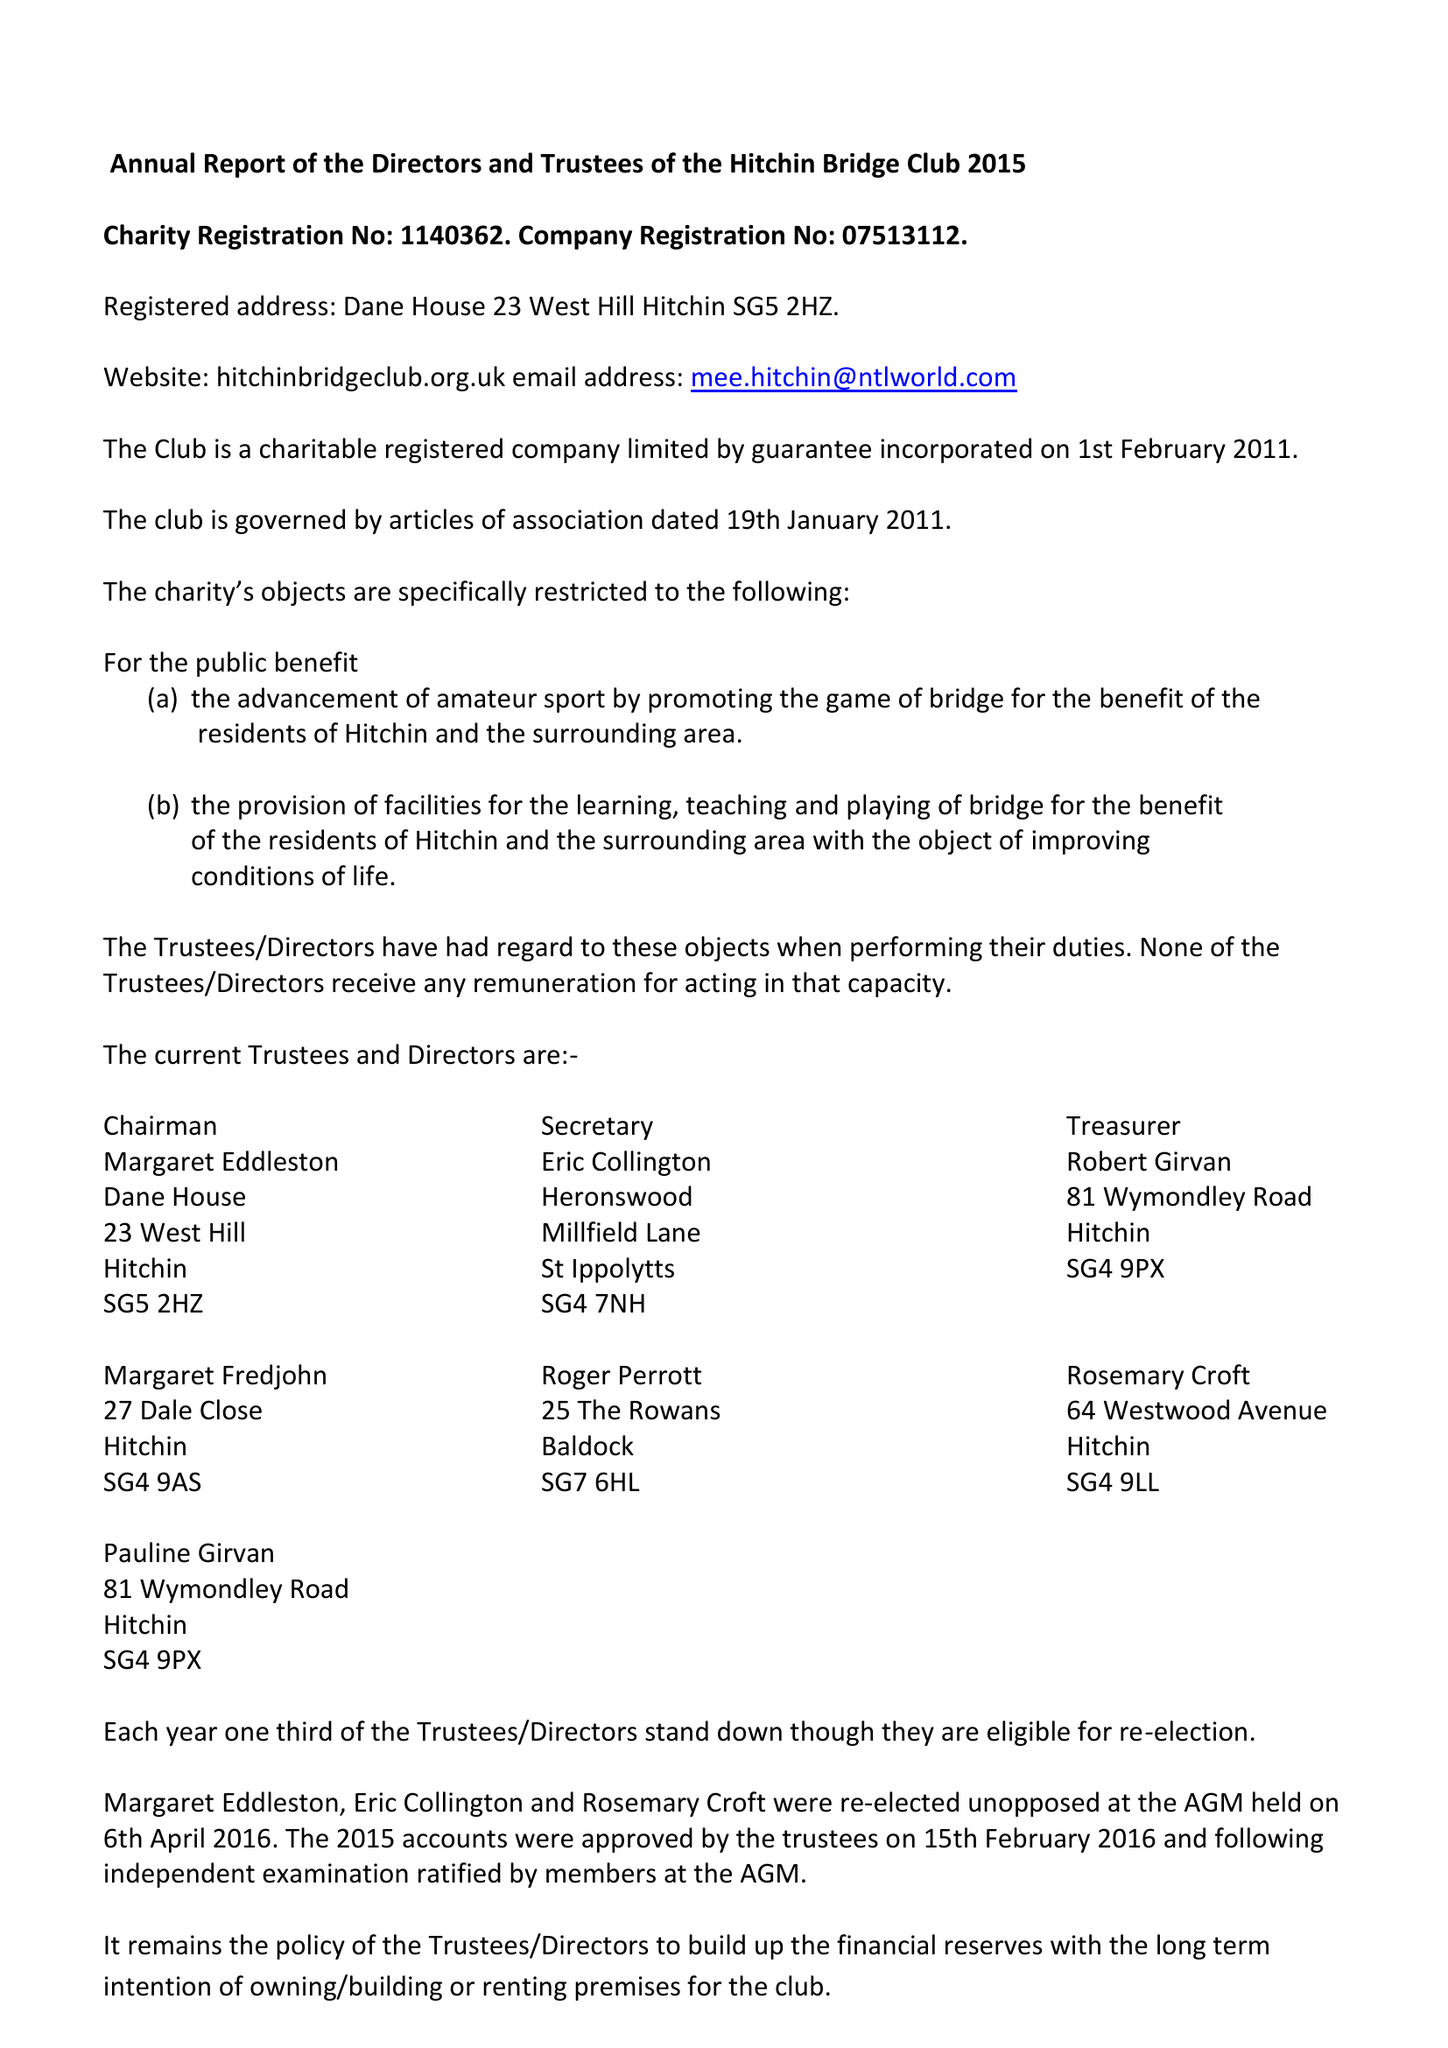What is the value for the address__postcode?
Answer the question using a single word or phrase. SG5 2HZ 